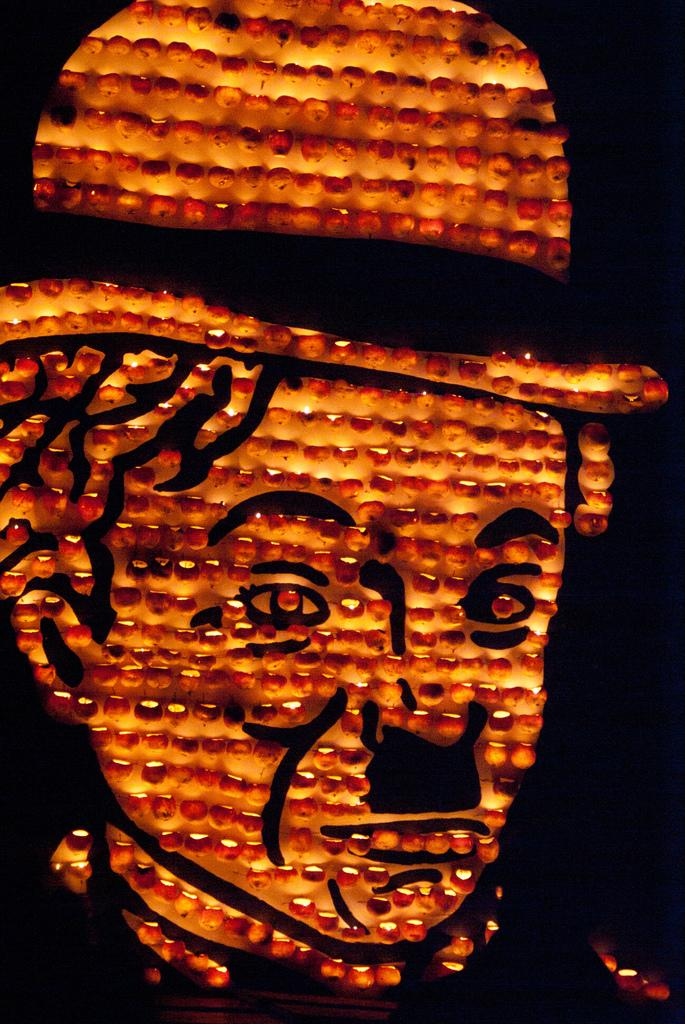What is the main subject of the image? There is an art piece in the image. What is depicted in the art piece? The art piece contains a drawing of a person. Are there any other elements visible in the image? Yes, there are lights visible in the image. What type of whip is being used by the person in the art piece? There is no whip present in the art piece; it only contains a drawing of a person. What color is the yarn used to create the person's clothing in the art piece? The art piece is a drawing, not a textile creation, so there is no yarn used in its creation. 